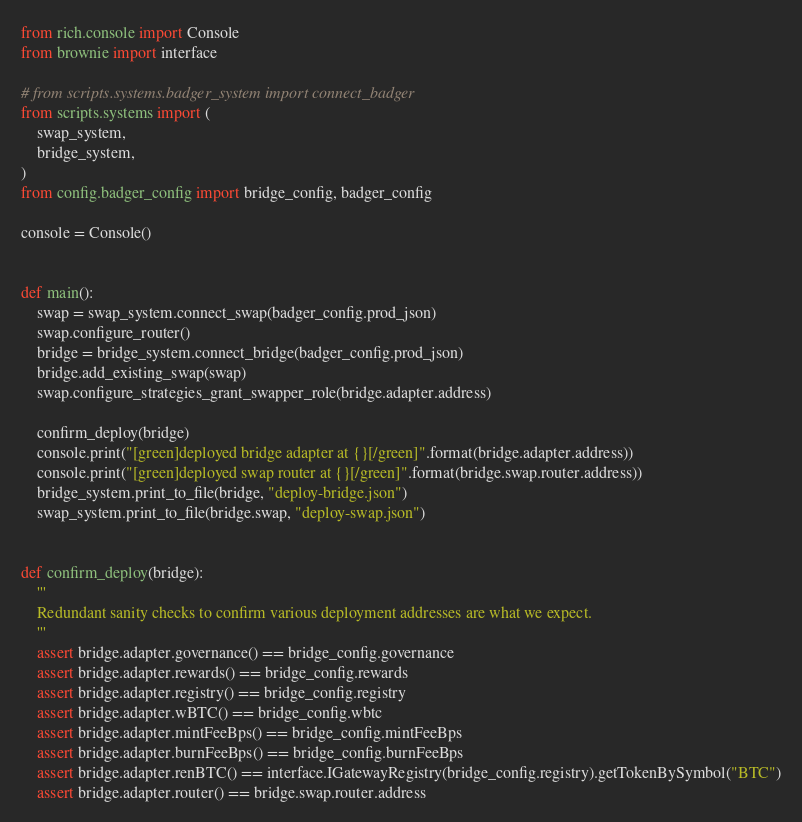<code> <loc_0><loc_0><loc_500><loc_500><_Python_>from rich.console import Console
from brownie import interface

# from scripts.systems.badger_system import connect_badger
from scripts.systems import (
    swap_system,
    bridge_system,
)
from config.badger_config import bridge_config, badger_config

console = Console()


def main():
    swap = swap_system.connect_swap(badger_config.prod_json)
    swap.configure_router()
    bridge = bridge_system.connect_bridge(badger_config.prod_json)
    bridge.add_existing_swap(swap)
    swap.configure_strategies_grant_swapper_role(bridge.adapter.address)

    confirm_deploy(bridge)
    console.print("[green]deployed bridge adapter at {}[/green]".format(bridge.adapter.address))
    console.print("[green]deployed swap router at {}[/green]".format(bridge.swap.router.address))
    bridge_system.print_to_file(bridge, "deploy-bridge.json")
    swap_system.print_to_file(bridge.swap, "deploy-swap.json")


def confirm_deploy(bridge):
    '''
    Redundant sanity checks to confirm various deployment addresses are what we expect.
    '''
    assert bridge.adapter.governance() == bridge_config.governance
    assert bridge.adapter.rewards() == bridge_config.rewards
    assert bridge.adapter.registry() == bridge_config.registry
    assert bridge.adapter.wBTC() == bridge_config.wbtc
    assert bridge.adapter.mintFeeBps() == bridge_config.mintFeeBps
    assert bridge.adapter.burnFeeBps() == bridge_config.burnFeeBps
    assert bridge.adapter.renBTC() == interface.IGatewayRegistry(bridge_config.registry).getTokenBySymbol("BTC")
    assert bridge.adapter.router() == bridge.swap.router.address

</code> 